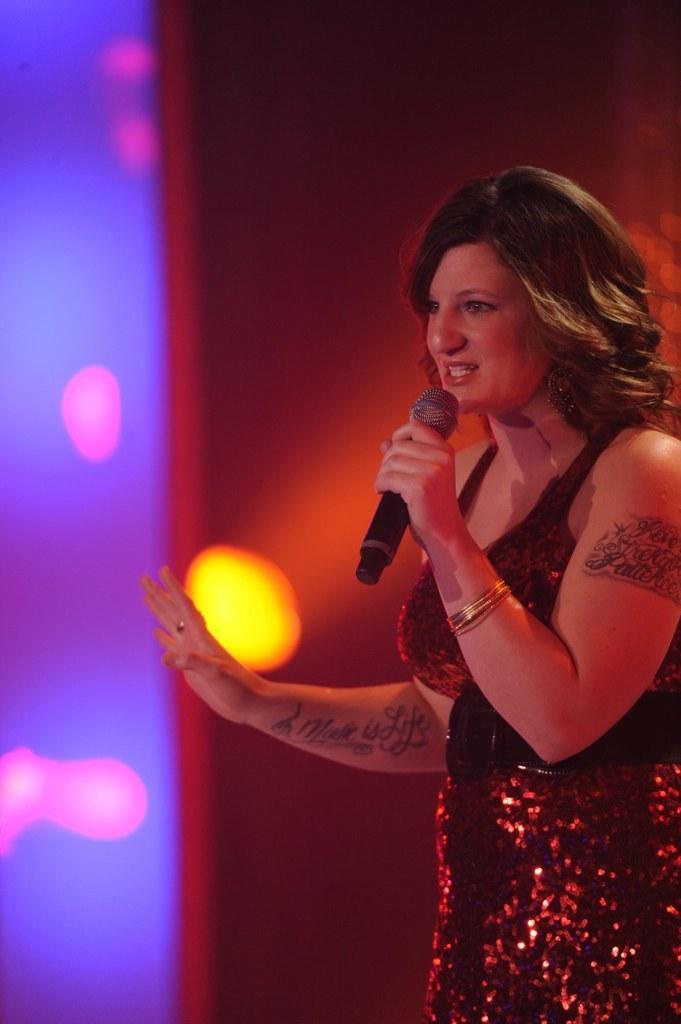Could you give a brief overview of what you see in this image? In this picture there is a woman holding a mic and singing. There are lights at the background. 